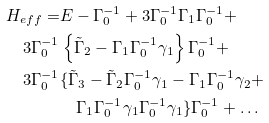Convert formula to latex. <formula><loc_0><loc_0><loc_500><loc_500>H _ { e f f } = & E - \Gamma _ { 0 } ^ { - 1 } + 3 \Gamma _ { 0 } ^ { - 1 } \Gamma _ { 1 } \Gamma _ { 0 } ^ { - 1 } + \\ 3 \Gamma _ { 0 } ^ { - 1 } & \left \{ \tilde { \Gamma } _ { 2 } - \Gamma _ { 1 } \Gamma _ { 0 } ^ { - 1 } \gamma _ { 1 } \right \} \Gamma _ { 0 } ^ { - 1 } + \\ 3 \Gamma _ { 0 } ^ { - 1 } & \{ \tilde { \Gamma } _ { 3 } - \tilde { \Gamma } _ { 2 } \Gamma _ { 0 } ^ { - 1 } \gamma _ { 1 } - \Gamma _ { 1 } \Gamma _ { 0 } ^ { - 1 } \gamma _ { 2 } + \\ & \quad \Gamma _ { 1 } \Gamma _ { 0 } ^ { - 1 } \gamma _ { 1 } \Gamma _ { 0 } ^ { - 1 } \gamma _ { 1 } \} \Gamma _ { 0 } ^ { - 1 } + \dots</formula> 